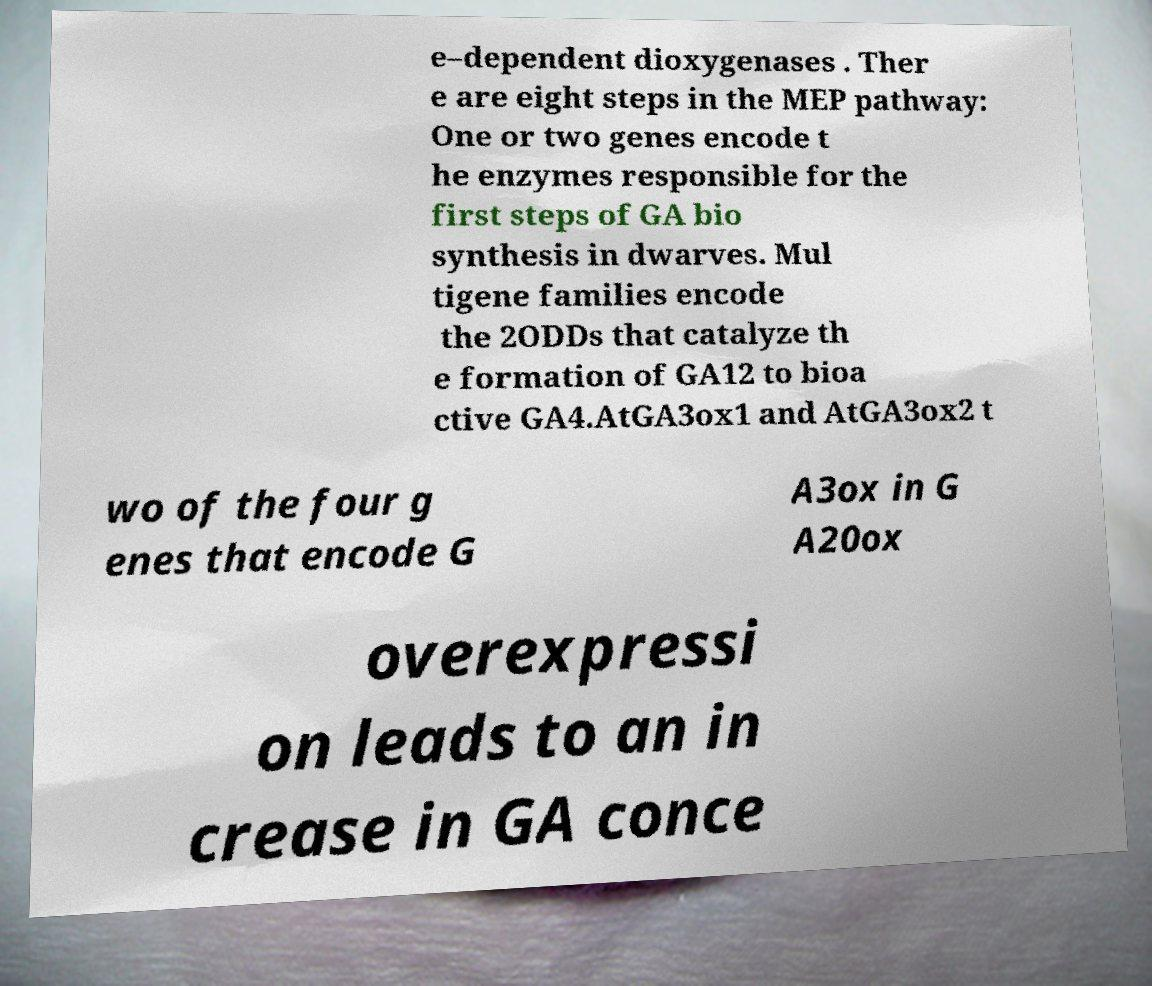Please read and relay the text visible in this image. What does it say? e–dependent dioxygenases . Ther e are eight steps in the MEP pathway: One or two genes encode t he enzymes responsible for the first steps of GA bio synthesis in dwarves. Mul tigene families encode the 2ODDs that catalyze th e formation of GA12 to bioa ctive GA4.AtGA3ox1 and AtGA3ox2 t wo of the four g enes that encode G A3ox in G A20ox overexpressi on leads to an in crease in GA conce 